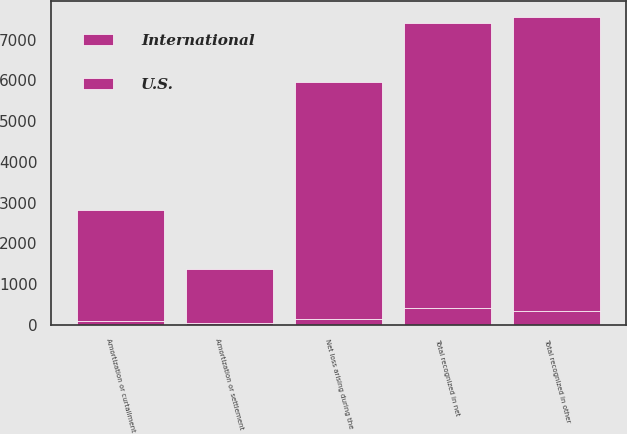Convert chart. <chart><loc_0><loc_0><loc_500><loc_500><stacked_bar_chart><ecel><fcel>Net loss arising during the<fcel>Amortization or curtailment<fcel>Amortization or settlement<fcel>Total recognized in other<fcel>Total recognized in net<nl><fcel>U.S.<fcel>5806<fcel>2730<fcel>1330<fcel>7206<fcel>6990<nl><fcel>International<fcel>149<fcel>96<fcel>53<fcel>351<fcel>422<nl></chart> 